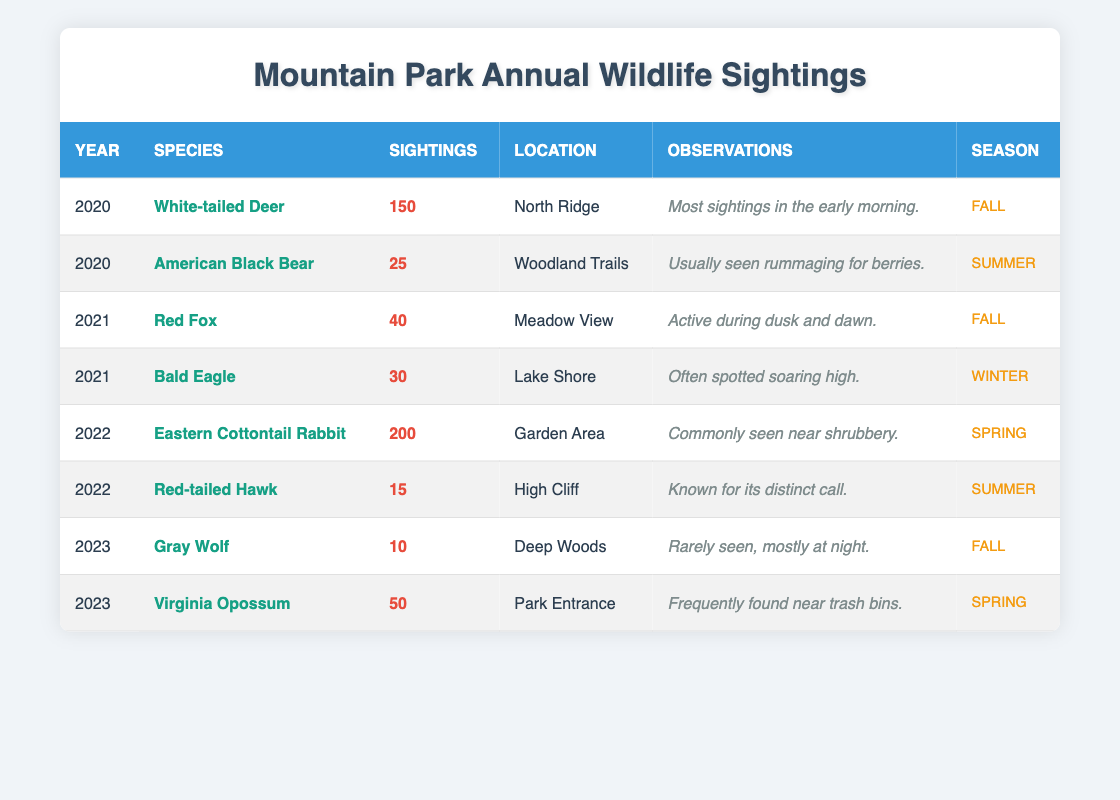What species had the highest number of sightings in 2022? In 2022, the only species listed are the Eastern Cottontail Rabbit and the Red-tailed Hawk. The Eastern Cottontail Rabbit had 200 sightings, while the Red-tailed Hawk had 15 sightings. Therefore, the species with the highest number of sightings is the Eastern Cottontail Rabbit.
Answer: Eastern Cottontail Rabbit How many sightings of wildlife were reported in total from 2020 to 2023? To answer this, we need to sum the sightings reported each year. The total sightings are: 150 (2020) + 25 (2020) + 40 (2021) + 30 (2021) + 200 (2022) + 15 (2022) + 10 (2023) + 50 (2023) = 520.
Answer: 520 Which location recorded the most sightings in 2020? In 2020, there are two species listed with sightings: White-tailed Deer (150 sightings) at North Ridge and American Black Bear (25 sightings) at Woodland Trails. The highest number of sightings in 2020 was at North Ridge with the White-tailed Deer.
Answer: North Ridge Did the number of sightings for Gray Wolves increase or decrease from previous years? The Gray Wolf had 10 sightings in 2023. Since this is the only year they were recorded, we cannot definitively state if their sightings increased or decreased, but they were not recorded in previous years, indicating a decrease from 0 to 10, showing limited sightings.
Answer: No decrease (not previously recorded) What season had the fewest sightings in 2022? In 2022, the sightings were: Eastern Cottontail Rabbit (200 in Spring), Red-tailed Hawk (15 in Summer). Since there are no sightings recorded for Fall or Winter in 2022, the season with the fewest sightings is Winter, as no sightings were reported.
Answer: Winter 